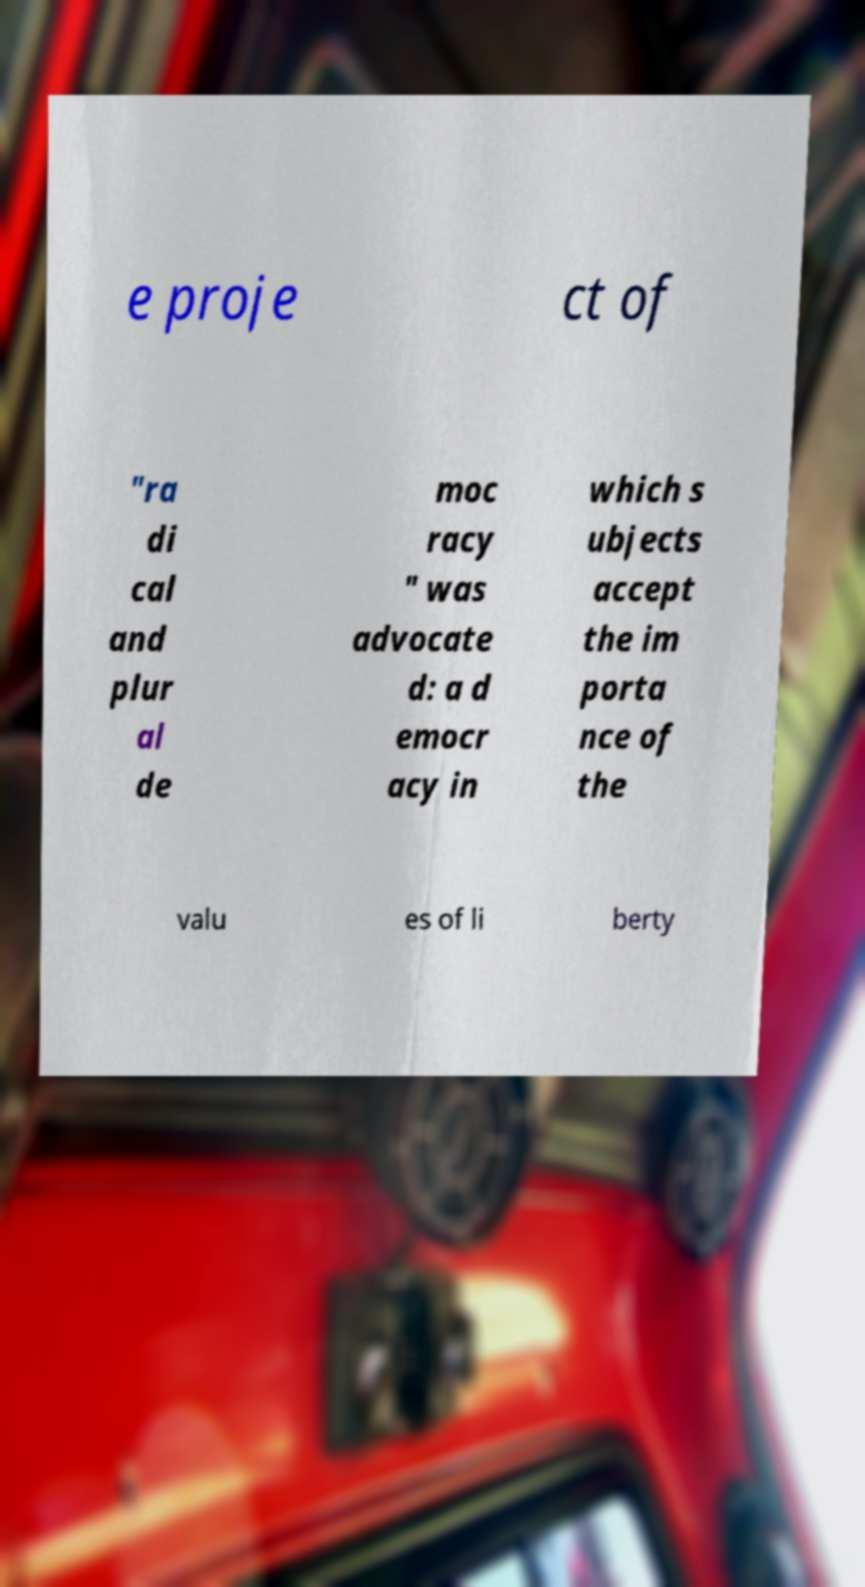Can you read and provide the text displayed in the image?This photo seems to have some interesting text. Can you extract and type it out for me? e proje ct of "ra di cal and plur al de moc racy " was advocate d: a d emocr acy in which s ubjects accept the im porta nce of the valu es of li berty 